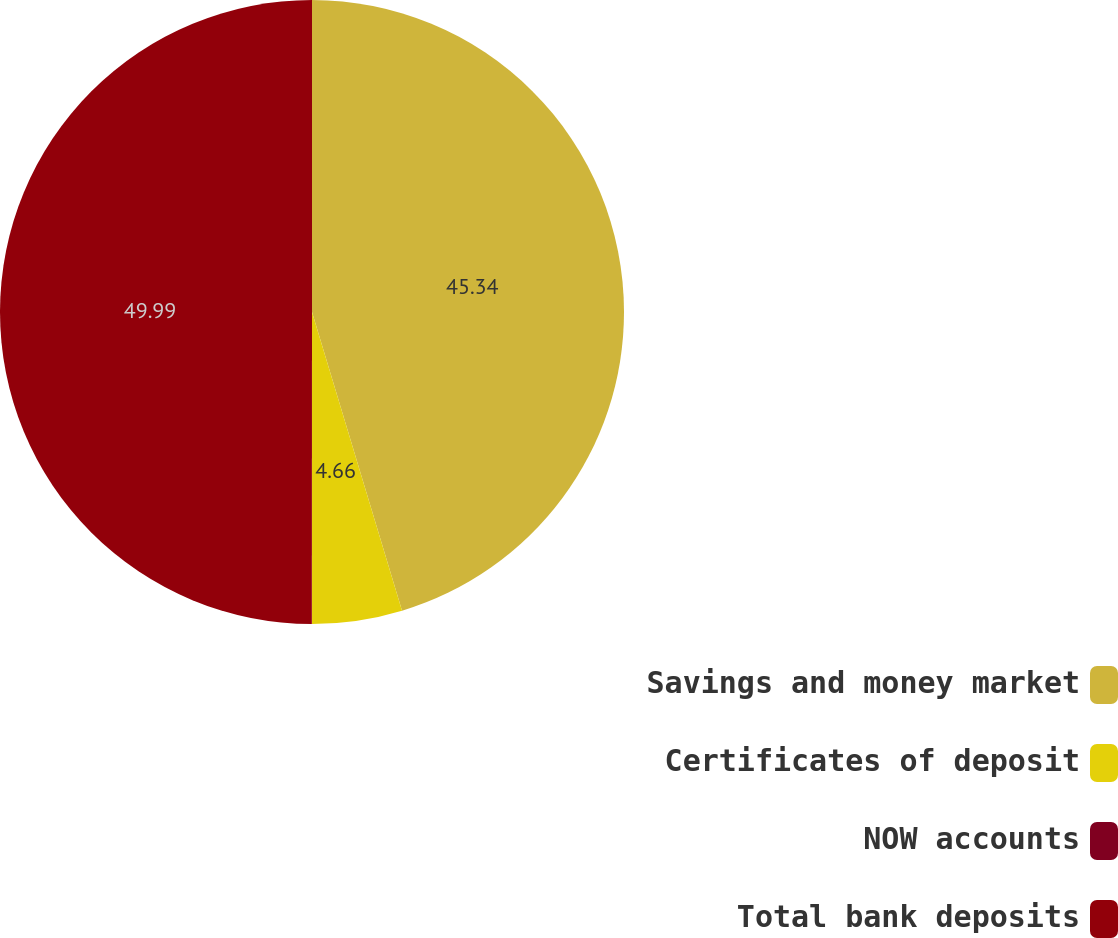<chart> <loc_0><loc_0><loc_500><loc_500><pie_chart><fcel>Savings and money market<fcel>Certificates of deposit<fcel>NOW accounts<fcel>Total bank deposits<nl><fcel>45.34%<fcel>4.66%<fcel>0.01%<fcel>49.99%<nl></chart> 